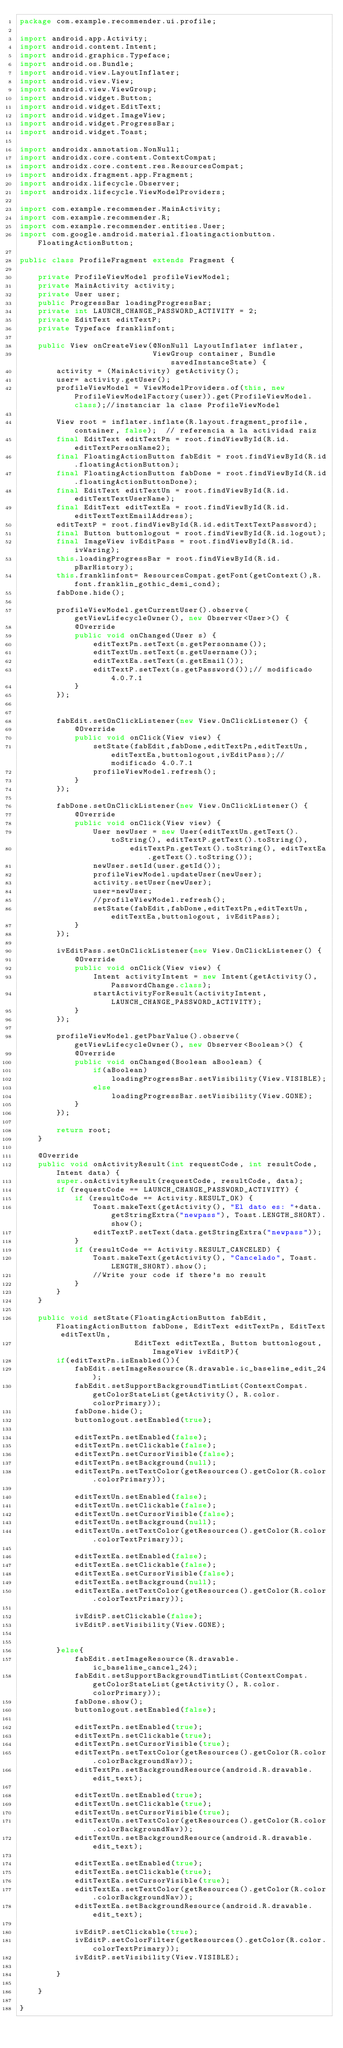<code> <loc_0><loc_0><loc_500><loc_500><_Java_>package com.example.recommender.ui.profile;

import android.app.Activity;
import android.content.Intent;
import android.graphics.Typeface;
import android.os.Bundle;
import android.view.LayoutInflater;
import android.view.View;
import android.view.ViewGroup;
import android.widget.Button;
import android.widget.EditText;
import android.widget.ImageView;
import android.widget.ProgressBar;
import android.widget.Toast;

import androidx.annotation.NonNull;
import androidx.core.content.ContextCompat;
import androidx.core.content.res.ResourcesCompat;
import androidx.fragment.app.Fragment;
import androidx.lifecycle.Observer;
import androidx.lifecycle.ViewModelProviders;

import com.example.recommender.MainActivity;
import com.example.recommender.R;
import com.example.recommender.entities.User;
import com.google.android.material.floatingactionbutton.FloatingActionButton;

public class ProfileFragment extends Fragment {

    private ProfileViewModel profileViewModel;
    private MainActivity activity;
    private User user;
    public ProgressBar loadingProgressBar;
    private int LAUNCH_CHANGE_PASSWORD_ACTIVITY = 2;
    private EditText editTextP;
    private Typeface franklinfont;

    public View onCreateView(@NonNull LayoutInflater inflater,
                             ViewGroup container, Bundle savedInstanceState) {
        activity = (MainActivity) getActivity();
        user= activity.getUser();
        profileViewModel = ViewModelProviders.of(this, new ProfileViewModelFactory(user)).get(ProfileViewModel.class);//instanciar la clase ProfileViewModel

        View root = inflater.inflate(R.layout.fragment_profile, container, false);  // referencia a la actividad raiz
        final EditText editTextPn = root.findViewById(R.id.editTextPersonName2);
        final FloatingActionButton fabEdit = root.findViewById(R.id.floatingActionButton);
        final FloatingActionButton fabDone = root.findViewById(R.id.floatingActionButtonDone);
        final EditText editTextUn = root.findViewById(R.id.editTextTextUserName);
        final EditText editTextEa = root.findViewById(R.id.editTextTextEmailAddress);
        editTextP = root.findViewById(R.id.editTextTextPassword);
        final Button buttonlogout = root.findViewById(R.id.logout);
        final ImageView ivEditPass = root.findViewById(R.id.ivWaring);
        this.loadingProgressBar = root.findViewById(R.id.pBarHistory);
        this.franklinfont= ResourcesCompat.getFont(getContext(),R.font.franklin_gothic_demi_cond);
        fabDone.hide();

        profileViewModel.getCurrentUser().observe(getViewLifecycleOwner(), new Observer<User>() {
            @Override
            public void onChanged(User s) {
                editTextPn.setText(s.getPersonname());
                editTextUn.setText(s.getUsername());
                editTextEa.setText(s.getEmail());
                editTextP.setText(s.getPassword());// modificado 4.0.7.1
            }
        });


        fabEdit.setOnClickListener(new View.OnClickListener() {
            @Override
            public void onClick(View view) {
                setState(fabEdit,fabDone,editTextPn,editTextUn,editTextEa,buttonlogout,ivEditPass);// modificado 4.0.7.1
                profileViewModel.refresh();
            }
        });

        fabDone.setOnClickListener(new View.OnClickListener() {
            @Override
            public void onClick(View view) {
                User newUser = new User(editTextUn.getText().toString(), editTextP.getText().toString(),
                        editTextPn.getText().toString(), editTextEa.getText().toString());
                newUser.setId(user.getId());
                profileViewModel.updateUser(newUser);
                activity.setUser(newUser);
                user=newUser;
                //profileViewModel.refresh();
                setState(fabEdit,fabDone,editTextPn,editTextUn,editTextEa,buttonlogout, ivEditPass);
            }
        });

        ivEditPass.setOnClickListener(new View.OnClickListener() {
            @Override
            public void onClick(View view) {
                Intent activityIntent = new Intent(getActivity(), PasswordChange.class);
                startActivityForResult(activityIntent, LAUNCH_CHANGE_PASSWORD_ACTIVITY);
            }
        });

        profileViewModel.getPbarValue().observe(getViewLifecycleOwner(), new Observer<Boolean>() {
            @Override
            public void onChanged(Boolean aBoolean) {
                if(aBoolean)
                    loadingProgressBar.setVisibility(View.VISIBLE);
                else
                    loadingProgressBar.setVisibility(View.GONE);
            }
        });

        return root;
    }

    @Override
    public void onActivityResult(int requestCode, int resultCode, Intent data) {
        super.onActivityResult(requestCode, resultCode, data);
        if (requestCode == LAUNCH_CHANGE_PASSWORD_ACTIVITY) {
            if (resultCode == Activity.RESULT_OK) {
                Toast.makeText(getActivity(), "El dato es: "+data.getStringExtra("newpass"), Toast.LENGTH_SHORT).show();
                editTextP.setText(data.getStringExtra("newpass"));
            }
            if (resultCode == Activity.RESULT_CANCELED) {
                Toast.makeText(getActivity(), "Cancelado", Toast.LENGTH_SHORT).show();
                //Write your code if there's no result
            }
        }
    }

    public void setState(FloatingActionButton fabEdit, FloatingActionButton fabDone, EditText editTextPn, EditText editTextUn,
                         EditText editTextEa, Button buttonlogout, ImageView ivEditP){
        if(editTextPn.isEnabled()){
            fabEdit.setImageResource(R.drawable.ic_baseline_edit_24);
            fabEdit.setSupportBackgroundTintList(ContextCompat.getColorStateList(getActivity(), R.color.colorPrimary));
            fabDone.hide();
            buttonlogout.setEnabled(true);

            editTextPn.setEnabled(false);
            editTextPn.setClickable(false);
            editTextPn.setCursorVisible(false);
            editTextPn.setBackground(null);
            editTextPn.setTextColor(getResources().getColor(R.color.colorPrimary));

            editTextUn.setEnabled(false);
            editTextUn.setClickable(false);
            editTextUn.setCursorVisible(false);
            editTextUn.setBackground(null);
            editTextUn.setTextColor(getResources().getColor(R.color.colorTextPrimary));

            editTextEa.setEnabled(false);
            editTextEa.setClickable(false);
            editTextEa.setCursorVisible(false);
            editTextEa.setBackground(null);
            editTextEa.setTextColor(getResources().getColor(R.color.colorTextPrimary));

            ivEditP.setClickable(false);
            ivEditP.setVisibility(View.GONE);


        }else{
            fabEdit.setImageResource(R.drawable.ic_baseline_cancel_24);
            fabEdit.setSupportBackgroundTintList(ContextCompat.getColorStateList(getActivity(), R.color.colorPrimary));
            fabDone.show();
            buttonlogout.setEnabled(false);

            editTextPn.setEnabled(true);
            editTextPn.setClickable(true);
            editTextPn.setCursorVisible(true);
            editTextPn.setTextColor(getResources().getColor(R.color.colorBackgroundNav));
            editTextPn.setBackgroundResource(android.R.drawable.edit_text);

            editTextUn.setEnabled(true);
            editTextUn.setClickable(true);
            editTextUn.setCursorVisible(true);
            editTextUn.setTextColor(getResources().getColor(R.color.colorBackgroundNav));
            editTextUn.setBackgroundResource(android.R.drawable.edit_text);

            editTextEa.setEnabled(true);
            editTextEa.setClickable(true);
            editTextEa.setCursorVisible(true);
            editTextEa.setTextColor(getResources().getColor(R.color.colorBackgroundNav));
            editTextEa.setBackgroundResource(android.R.drawable.edit_text);

            ivEditP.setClickable(true);
            ivEditP.setColorFilter(getResources().getColor(R.color.colorTextPrimary));
            ivEditP.setVisibility(View.VISIBLE);

        }

    }

}</code> 